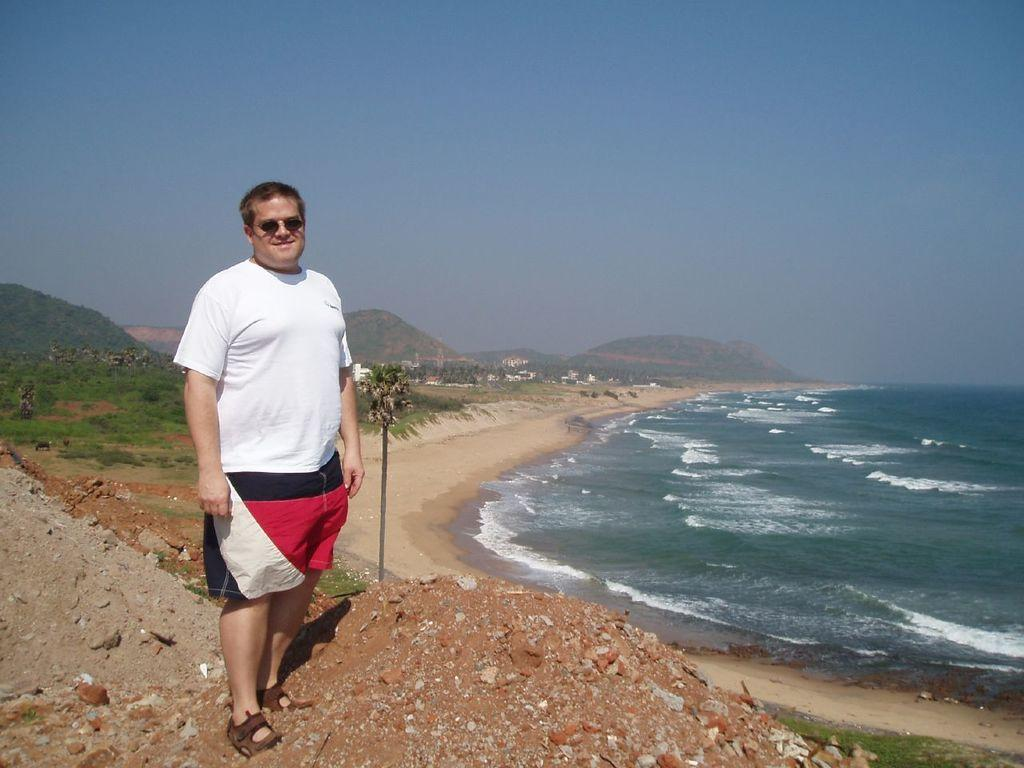What is the main subject in the front of the image? There is a person in the front of the image. What is the person wearing? The person is wearing goggles. What type of terrain is visible in the front of the image? There is sand, rocks, and grass in the front of the image. What can be seen in the background of the image? There are trees, hills, grass, water, and the sky visible in the background of the image. What type of plastic is being used to pick the berries in the image? There are no berries or plastic visible in the image. How does the person's digestion system work in the image? There is no information about the person's digestion system in the image. 